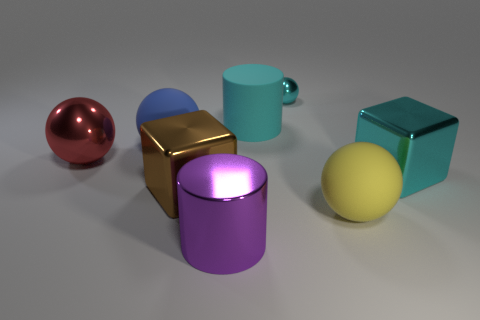Subtract all red metallic balls. How many balls are left? 3 Subtract all red balls. How many balls are left? 3 Add 2 big purple shiny cylinders. How many objects exist? 10 Subtract all brown balls. Subtract all purple blocks. How many balls are left? 4 Subtract all cubes. How many objects are left? 6 Subtract all big purple cylinders. Subtract all yellow rubber spheres. How many objects are left? 6 Add 5 big blue things. How many big blue things are left? 6 Add 8 matte cylinders. How many matte cylinders exist? 9 Subtract 0 blue cylinders. How many objects are left? 8 